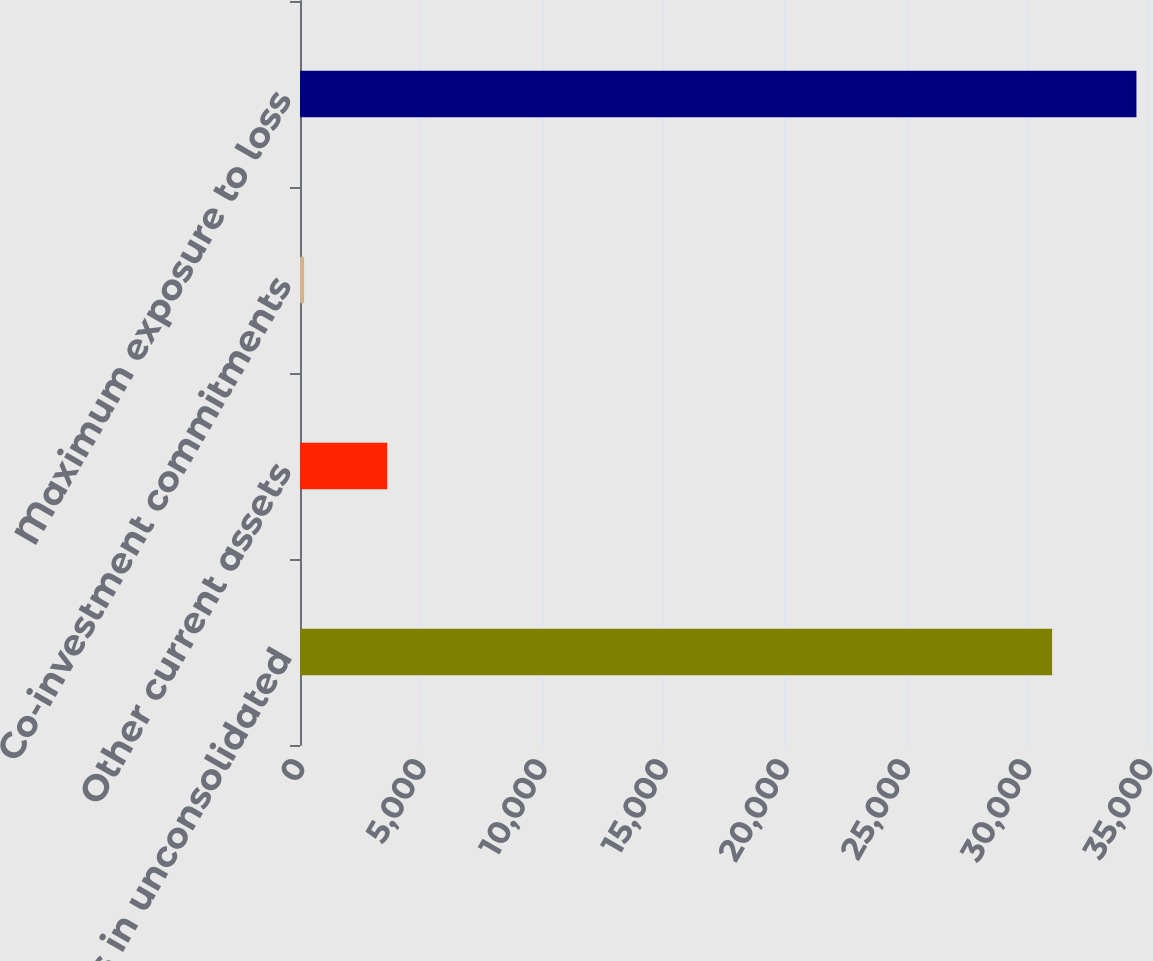Convert chart. <chart><loc_0><loc_0><loc_500><loc_500><bar_chart><fcel>Investments in unconsolidated<fcel>Other current assets<fcel>Co-investment commitments<fcel>Maximum exposure to loss<nl><fcel>31041<fcel>3603.5<fcel>168<fcel>34523<nl></chart> 